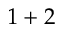Convert formula to latex. <formula><loc_0><loc_0><loc_500><loc_500>1 + 2</formula> 